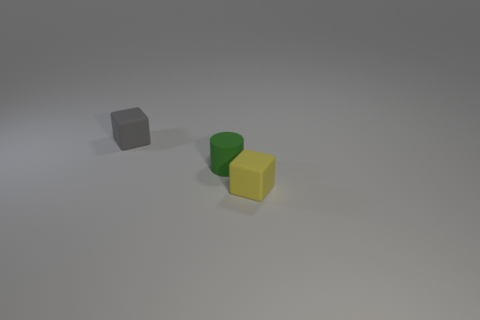There is a small block right of the small gray block left of the green rubber thing; is there a small rubber cylinder in front of it? Based on the image, there is no small rubber cylinder in front of the gray block. The only objects present are a small gray block, a green rubber cylinder, and a yellow cube. The green rubber cylinder is positioned beside the gray block, not in front. 